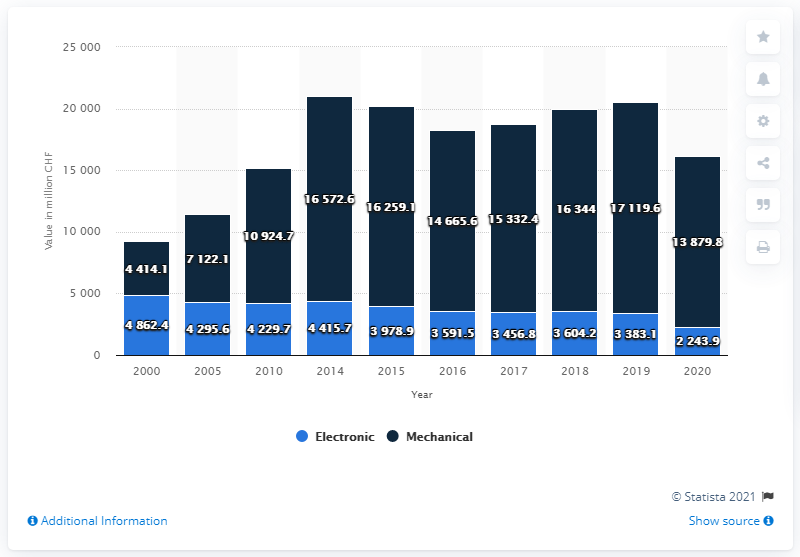Point out several critical features in this image. The global export value of mechanical Swiss watches in 2020 was 13,879.8 million US dollars. 